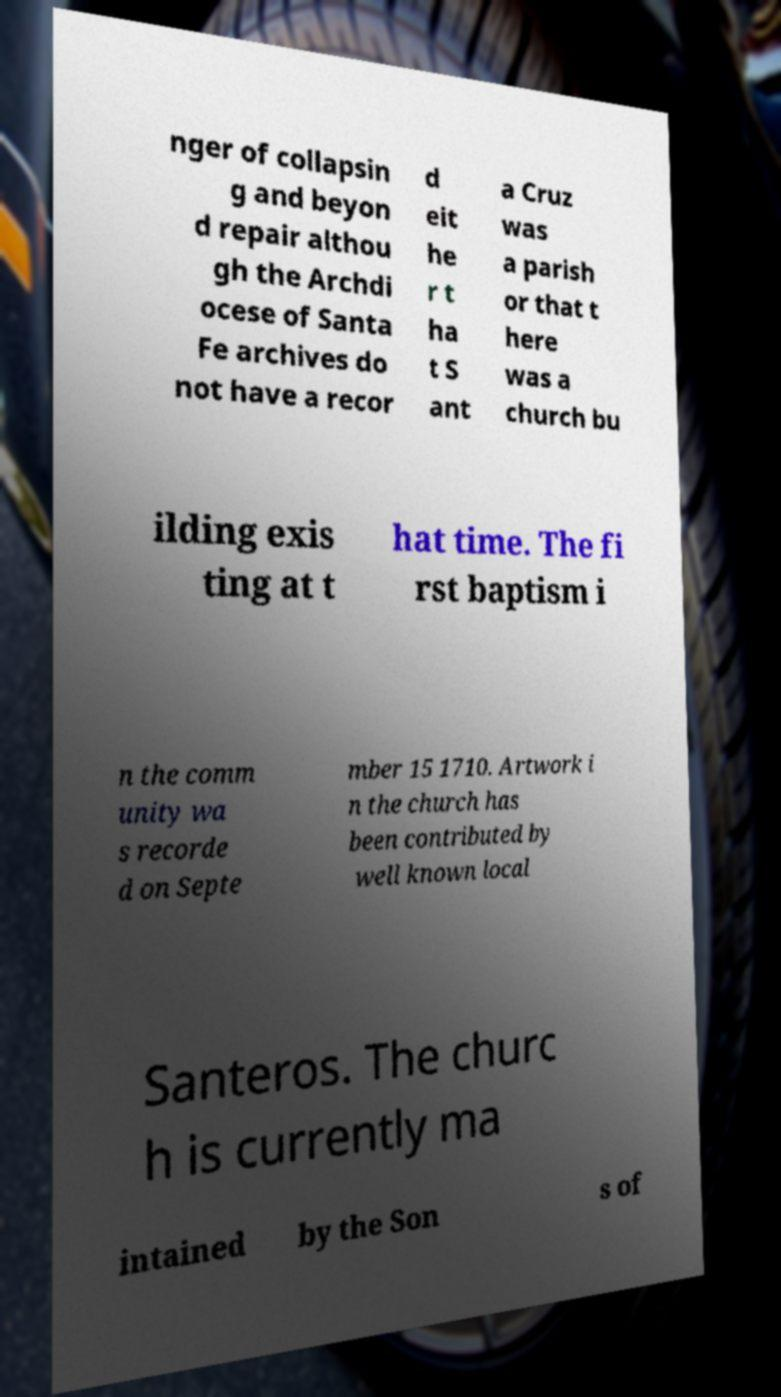Please identify and transcribe the text found in this image. nger of collapsin g and beyon d repair althou gh the Archdi ocese of Santa Fe archives do not have a recor d eit he r t ha t S ant a Cruz was a parish or that t here was a church bu ilding exis ting at t hat time. The fi rst baptism i n the comm unity wa s recorde d on Septe mber 15 1710. Artwork i n the church has been contributed by well known local Santeros. The churc h is currently ma intained by the Son s of 